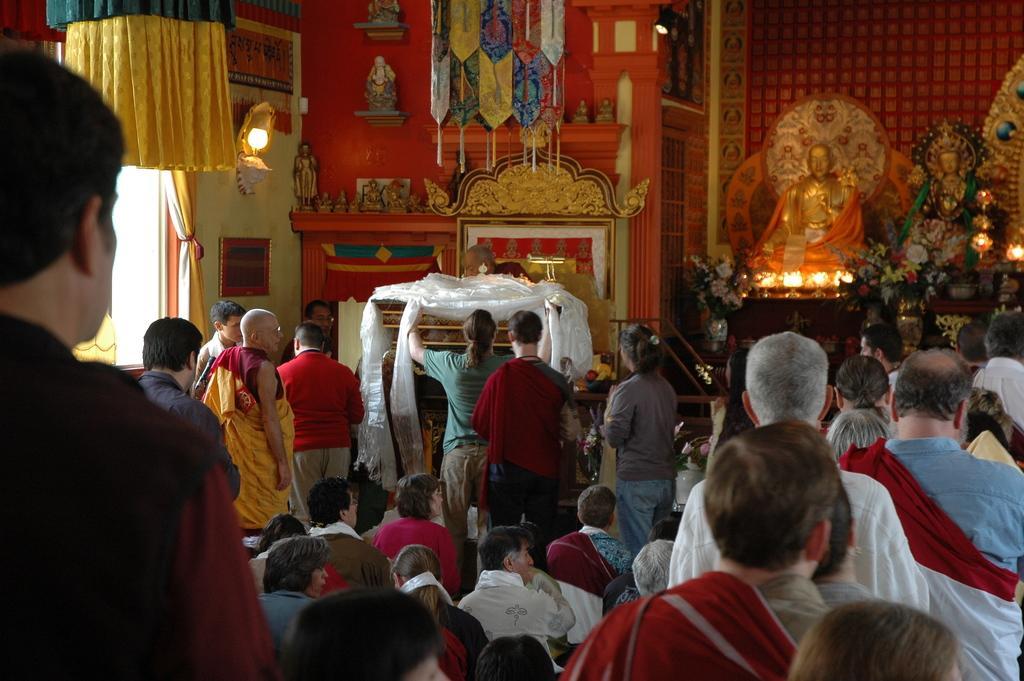Please provide a concise description of this image. Here people are standing, here some people are sitting, here there are sculptures, this is light, there is a photo frame on the wall. 